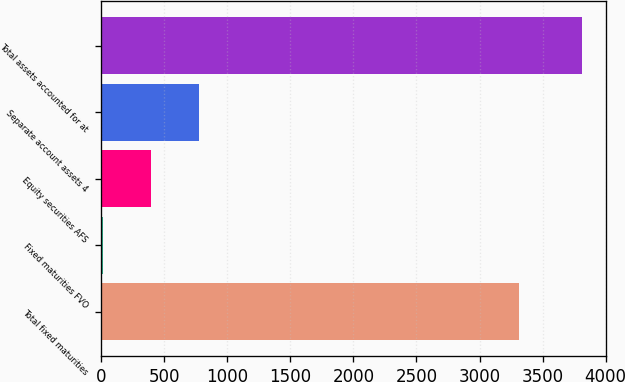Convert chart. <chart><loc_0><loc_0><loc_500><loc_500><bar_chart><fcel>Total fixed maturities<fcel>Fixed maturities FVO<fcel>Equity securities AFS<fcel>Separate account assets 4<fcel>Total assets accounted for at<nl><fcel>3313<fcel>16<fcel>395.4<fcel>774.8<fcel>3810<nl></chart> 